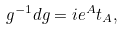<formula> <loc_0><loc_0><loc_500><loc_500>g ^ { - 1 } d g = i e ^ { A } t _ { A } ,</formula> 